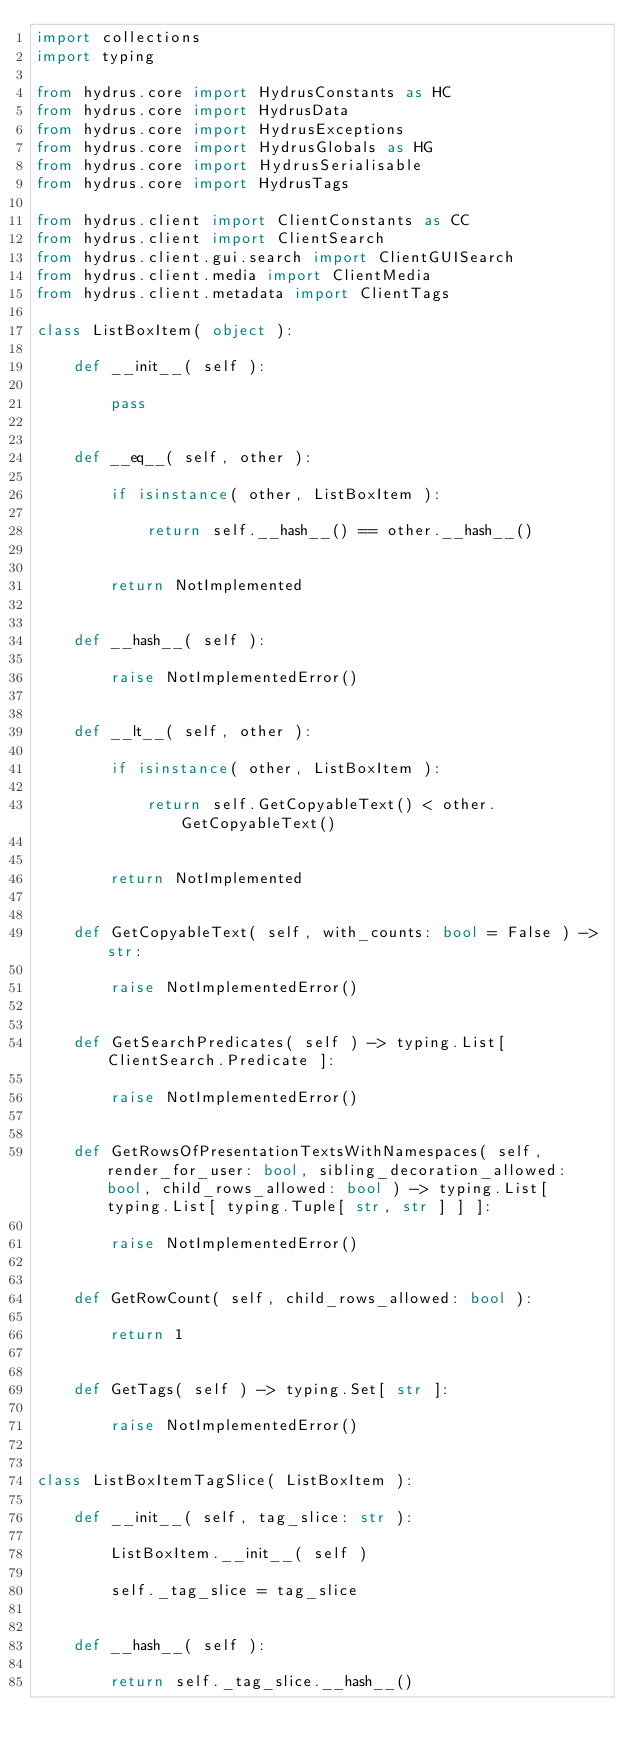Convert code to text. <code><loc_0><loc_0><loc_500><loc_500><_Python_>import collections
import typing

from hydrus.core import HydrusConstants as HC
from hydrus.core import HydrusData
from hydrus.core import HydrusExceptions
from hydrus.core import HydrusGlobals as HG
from hydrus.core import HydrusSerialisable
from hydrus.core import HydrusTags

from hydrus.client import ClientConstants as CC
from hydrus.client import ClientSearch
from hydrus.client.gui.search import ClientGUISearch
from hydrus.client.media import ClientMedia
from hydrus.client.metadata import ClientTags

class ListBoxItem( object ):
    
    def __init__( self ):
        
        pass
        
    
    def __eq__( self, other ):
        
        if isinstance( other, ListBoxItem ):
            
            return self.__hash__() == other.__hash__()
            
        
        return NotImplemented
        
    
    def __hash__( self ):
        
        raise NotImplementedError()
        
    
    def __lt__( self, other ):
        
        if isinstance( other, ListBoxItem ):
            
            return self.GetCopyableText() < other.GetCopyableText()
            
        
        return NotImplemented
        
    
    def GetCopyableText( self, with_counts: bool = False ) -> str:
        
        raise NotImplementedError()
        
    
    def GetSearchPredicates( self ) -> typing.List[ ClientSearch.Predicate ]:
        
        raise NotImplementedError()
        
    
    def GetRowsOfPresentationTextsWithNamespaces( self, render_for_user: bool, sibling_decoration_allowed: bool, child_rows_allowed: bool ) -> typing.List[ typing.List[ typing.Tuple[ str, str ] ] ]:
        
        raise NotImplementedError()
        
    
    def GetRowCount( self, child_rows_allowed: bool ):
        
        return 1
        
    
    def GetTags( self ) -> typing.Set[ str ]:
        
        raise NotImplementedError()
        
    
class ListBoxItemTagSlice( ListBoxItem ):
    
    def __init__( self, tag_slice: str ):
        
        ListBoxItem.__init__( self )
        
        self._tag_slice = tag_slice
        
    
    def __hash__( self ):
        
        return self._tag_slice.__hash__()
        
    </code> 